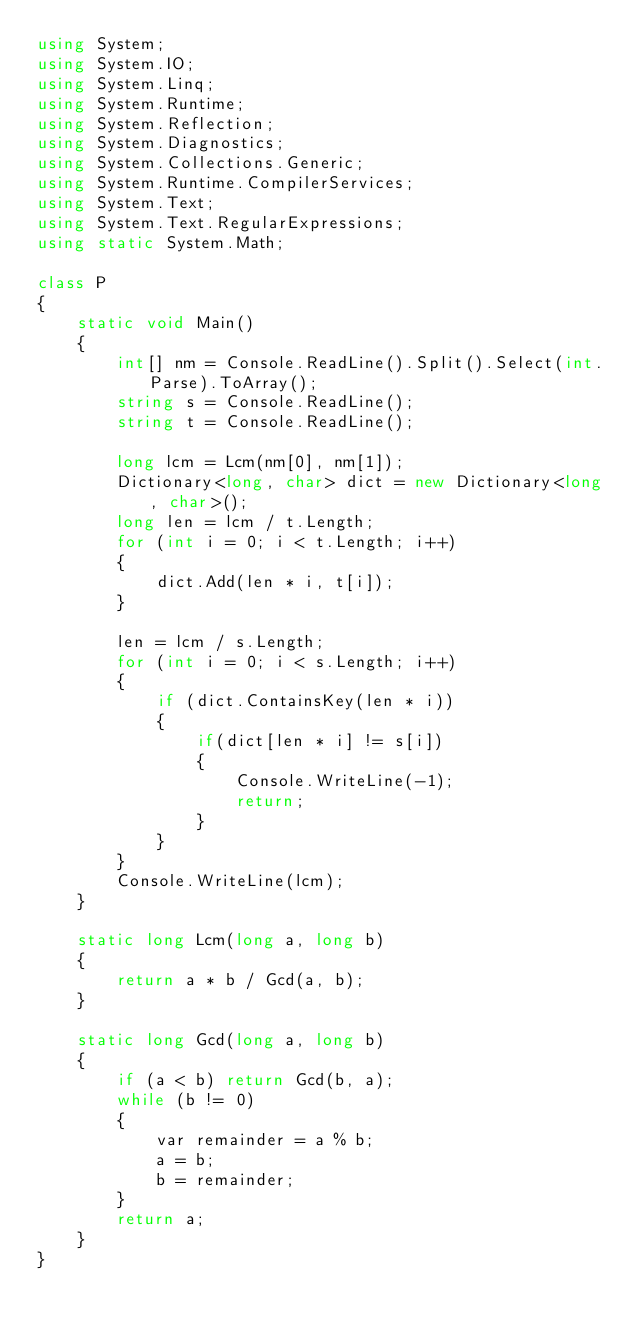<code> <loc_0><loc_0><loc_500><loc_500><_C#_>using System;
using System.IO;
using System.Linq;
using System.Runtime;
using System.Reflection;
using System.Diagnostics;
using System.Collections.Generic;
using System.Runtime.CompilerServices;
using System.Text;
using System.Text.RegularExpressions;
using static System.Math;

class P
{
    static void Main()
    {
        int[] nm = Console.ReadLine().Split().Select(int.Parse).ToArray();
        string s = Console.ReadLine();
        string t = Console.ReadLine();

        long lcm = Lcm(nm[0], nm[1]);
        Dictionary<long, char> dict = new Dictionary<long, char>();
        long len = lcm / t.Length;
        for (int i = 0; i < t.Length; i++)
        {
            dict.Add(len * i, t[i]);
        }

        len = lcm / s.Length;
        for (int i = 0; i < s.Length; i++)
        {
            if (dict.ContainsKey(len * i))
            {
                if(dict[len * i] != s[i])
                {
                    Console.WriteLine(-1);
                    return;
                }
            }
        }
        Console.WriteLine(lcm);
    }

    static long Lcm(long a, long b)
    {
        return a * b / Gcd(a, b);
    }

    static long Gcd(long a, long b)
    {
        if (a < b) return Gcd(b, a);
        while (b != 0)
        {
            var remainder = a % b;
            a = b;
            b = remainder;
        }
        return a;
    }
}</code> 